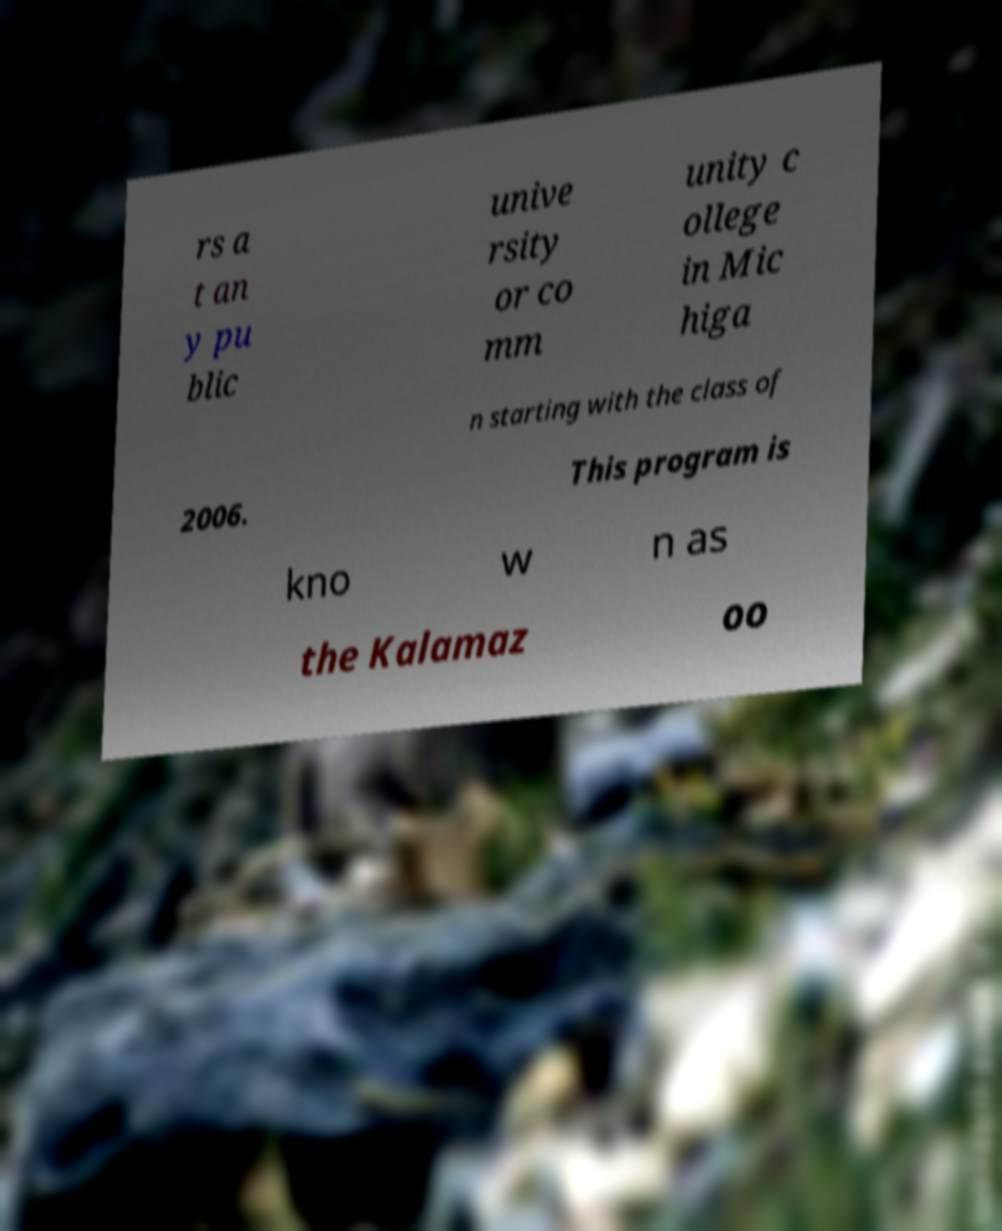Please identify and transcribe the text found in this image. rs a t an y pu blic unive rsity or co mm unity c ollege in Mic higa n starting with the class of 2006. This program is kno w n as the Kalamaz oo 